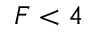Convert formula to latex. <formula><loc_0><loc_0><loc_500><loc_500>F < 4</formula> 